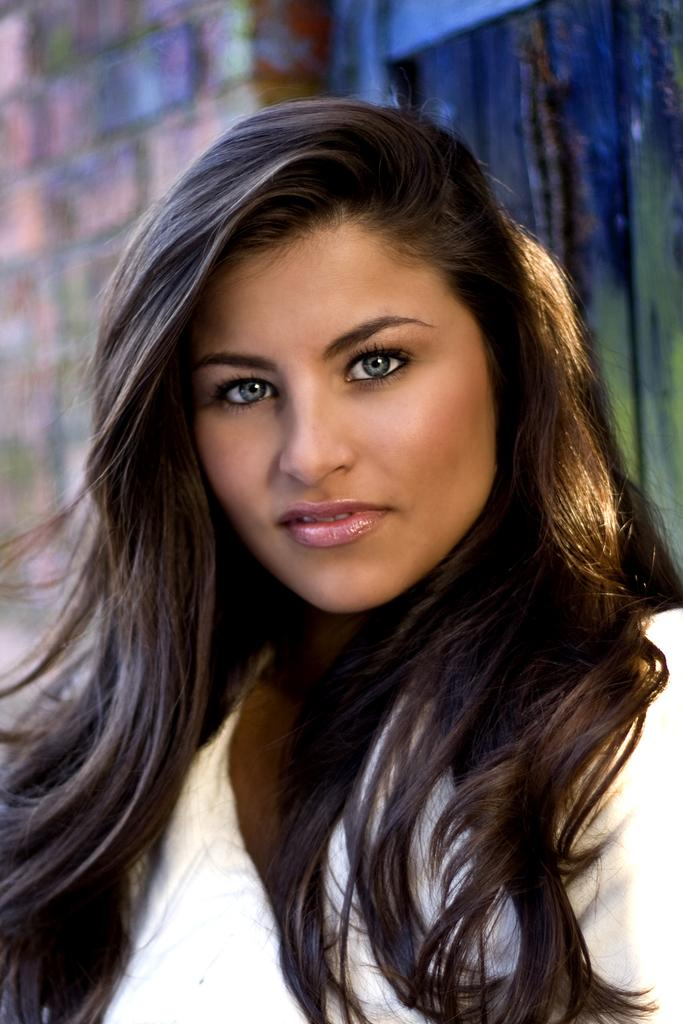What is the main subject of the image? The main subject of the image is a woman. Where is the woman located in the image? The woman is in the middle of the image. What can be seen in the background of the image? There is a wall in the background of the image. What type of credit can be seen being used by the woman in the image? There is no credit being used by the woman in the image. What type of flesh can be seen on the woman's body in the image? The image does not show any specific type of flesh on the woman's body. 